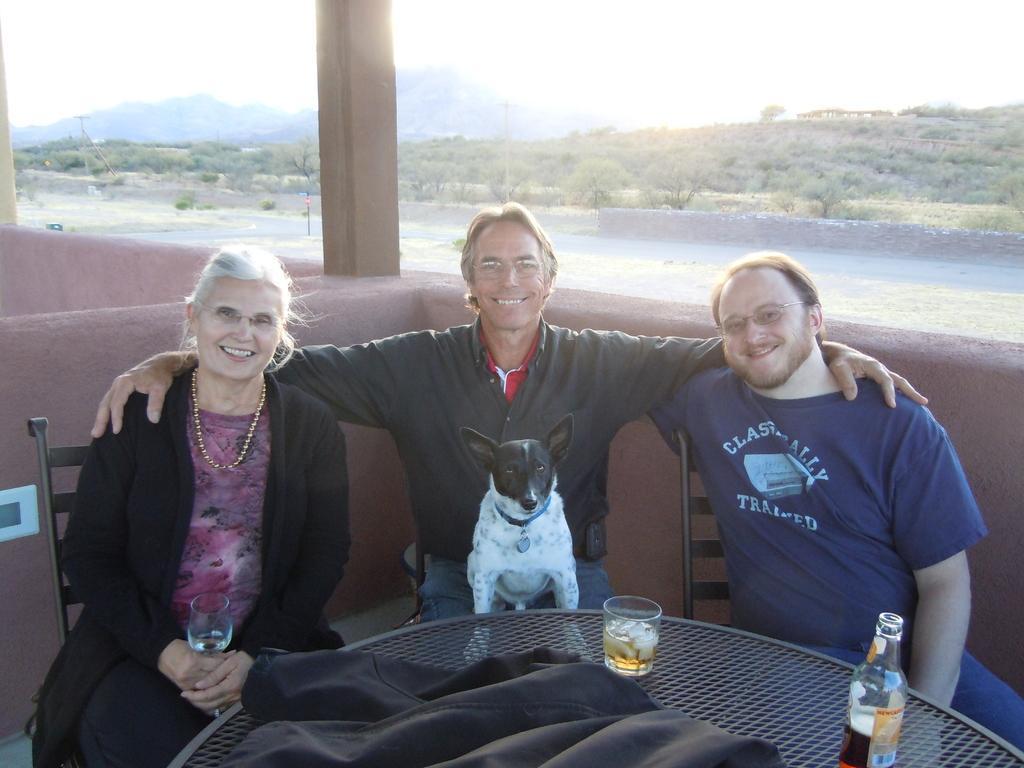Describe this image in one or two sentences. In this image I can see three persons are sitting in chairs which are black in color and I can see a woman is holding a glass in her hand. I can see a dog which is white and black in color on a person's lap. In front of them I can see a table which is black in color and on the table I can see a glass, a bottle and a cloth. In the background I can see the ground, the wall, few trees, few mountains and the sky. 